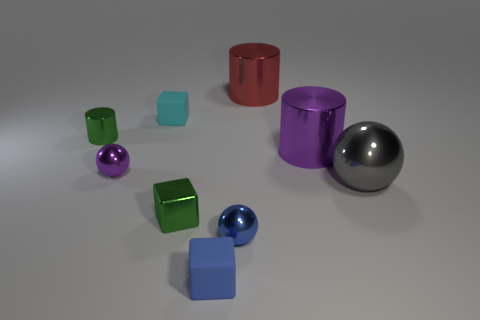What shape is the big purple object that is the same material as the purple sphere?
Your answer should be very brief. Cylinder. Are there fewer cyan blocks than brown blocks?
Give a very brief answer. No. Is the material of the gray object the same as the cyan cube?
Your answer should be very brief. No. What number of other objects are the same color as the tiny shiny cylinder?
Provide a short and direct response. 1. Are there more blue matte blocks than objects?
Make the answer very short. No. Do the cyan thing and the purple metal object right of the metal block have the same size?
Provide a succinct answer. No. There is a tiny object that is right of the small blue rubber thing; what color is it?
Offer a terse response. Blue. What number of blue objects are either tiny rubber things or big objects?
Ensure brevity in your answer.  1. The metal cube is what color?
Make the answer very short. Green. Are there any other things that are the same material as the gray object?
Ensure brevity in your answer.  Yes. 